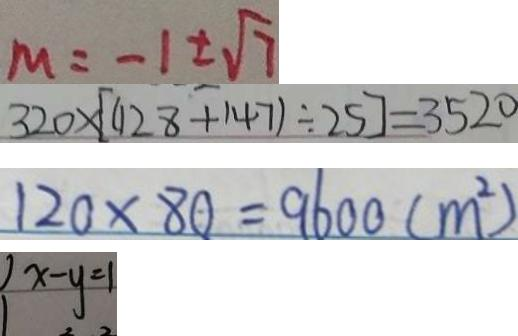Convert formula to latex. <formula><loc_0><loc_0><loc_500><loc_500>M = - 1 \pm \sqrt { 7 } 
 3 2 0 \times [ ( 1 2 8 + 1 4 7 ) \div 2 5 ] = 3 5 2 0 
 1 2 0 \times 8 0 = 9 6 0 0 ( m ^ { 2 } ) 
 x - y = 1</formula> 